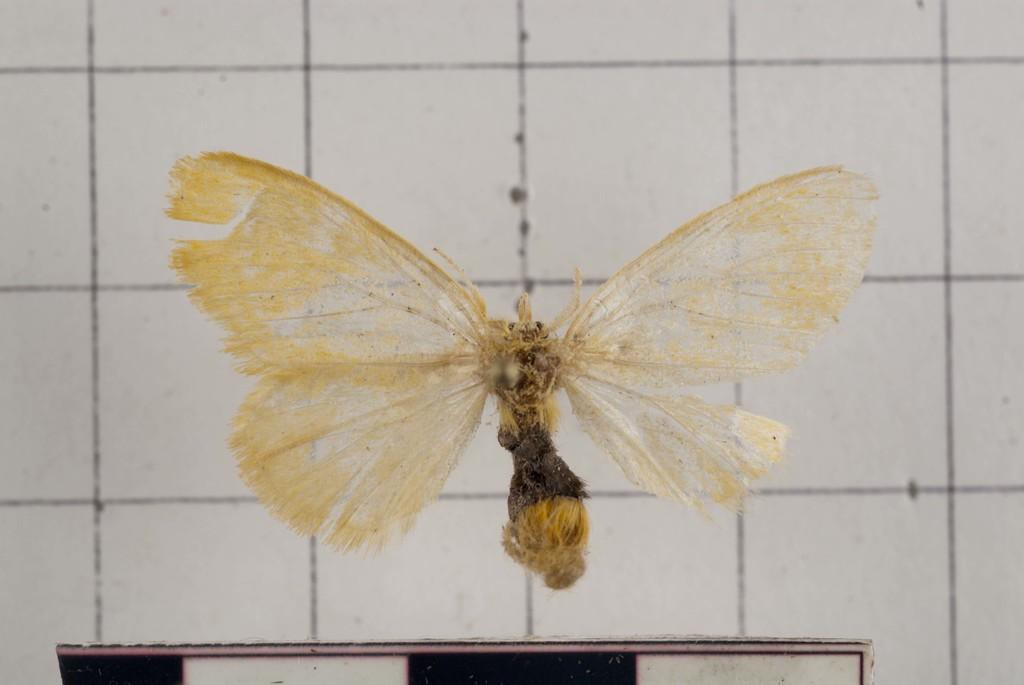What is the main subject in the center of the image? There is a butterfly in the center of the image. What can be seen in the background of the image? There is a wall in the background of the image. How many snakes are crawling on the paper in the image? There are no snakes or paper present in the image; it features a butterfly and a wall in the background. 